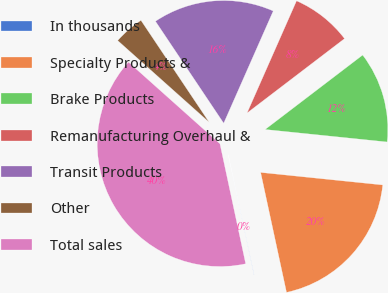Convert chart. <chart><loc_0><loc_0><loc_500><loc_500><pie_chart><fcel>In thousands<fcel>Specialty Products &<fcel>Brake Products<fcel>Remanufacturing Overhaul &<fcel>Transit Products<fcel>Other<fcel>Total sales<nl><fcel>0.02%<fcel>19.99%<fcel>12.0%<fcel>8.01%<fcel>16.0%<fcel>4.01%<fcel>39.96%<nl></chart> 